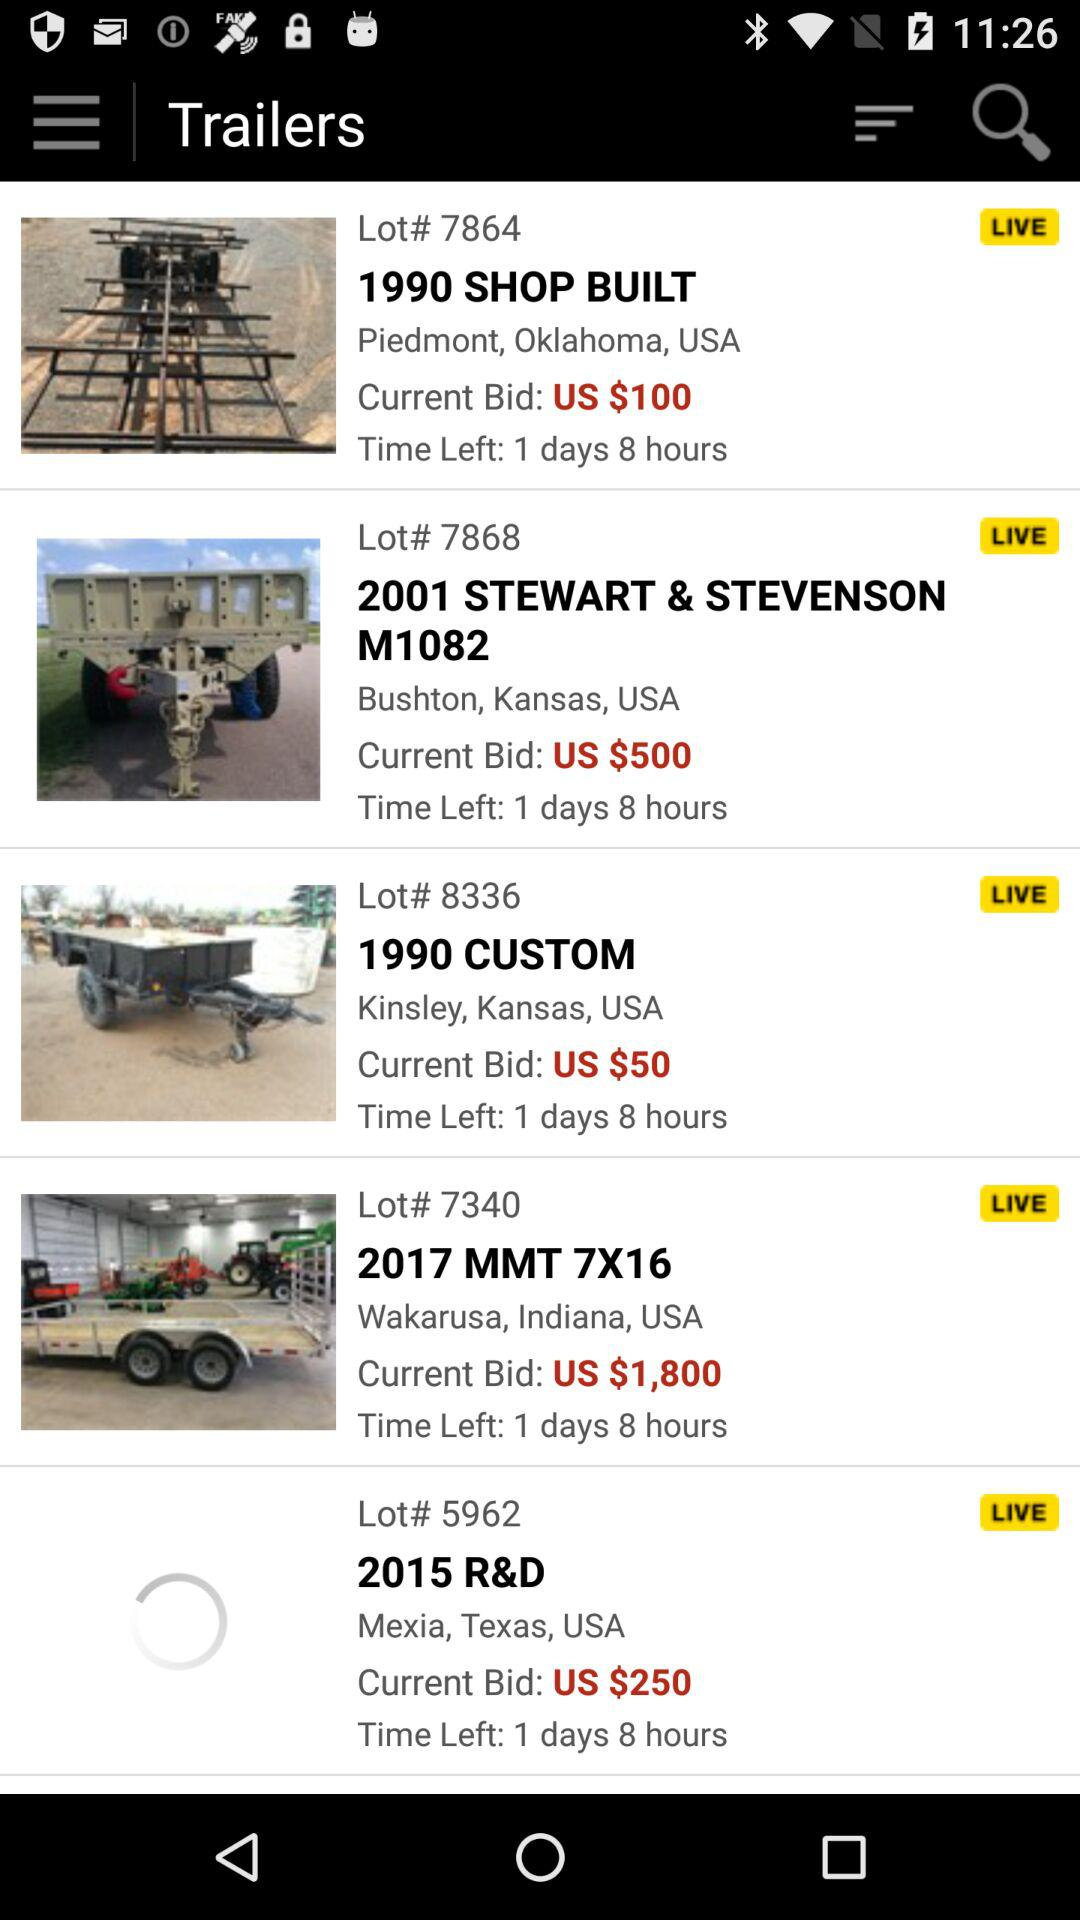How much is the difference between the highest and lowest current bids?
Answer the question using a single word or phrase. 1750 